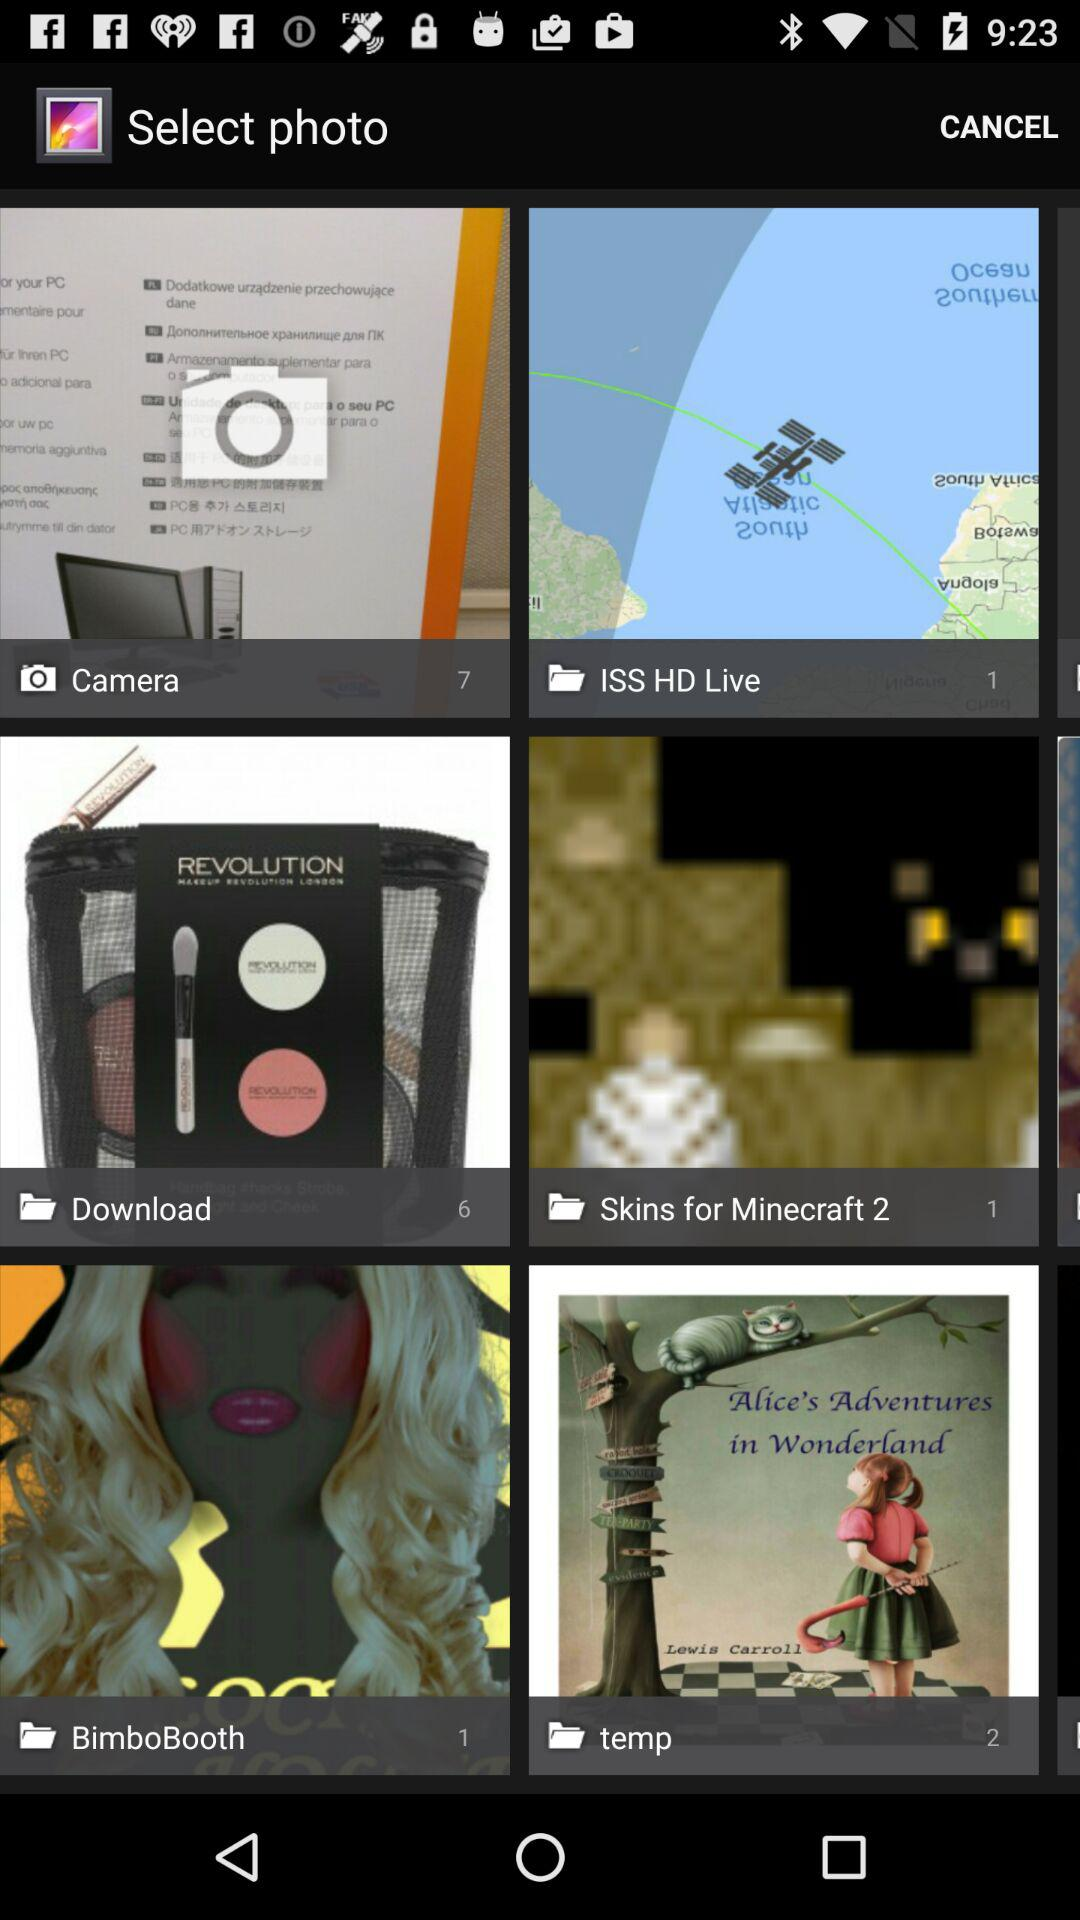What folder has 6 photos? The download folder has 6 photos. 